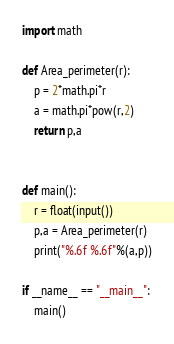<code> <loc_0><loc_0><loc_500><loc_500><_Python_>import math

def Area_perimeter(r):
    p = 2*math.pi*r
    a = math.pi*pow(r,2)
    return p,a


def main():
    r = float(input())
    p,a = Area_perimeter(r)
    print("%.6f %.6f"%(a,p))

if __name__ == "__main__":
    main()
</code> 